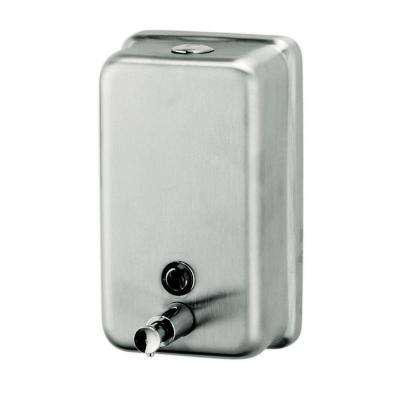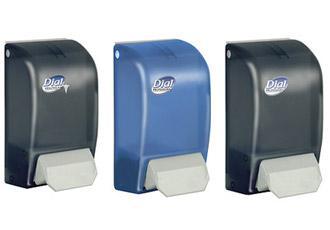The first image is the image on the left, the second image is the image on the right. For the images shown, is this caption "An image shows exactly three dispensers in a row, with at least two of them the same style." true? Answer yes or no. Yes. The first image is the image on the left, the second image is the image on the right. Evaluate the accuracy of this statement regarding the images: "in at least one image there are three wall soap dispensers.". Is it true? Answer yes or no. Yes. 